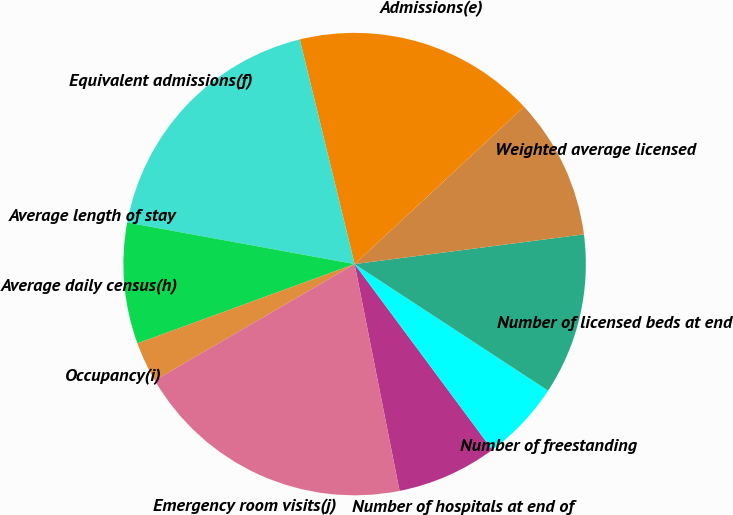<chart> <loc_0><loc_0><loc_500><loc_500><pie_chart><fcel>Number of hospitals at end of<fcel>Number of freestanding<fcel>Number of licensed beds at end<fcel>Weighted average licensed<fcel>Admissions(e)<fcel>Equivalent admissions(f)<fcel>Average length of stay<fcel>Average daily census(h)<fcel>Occupancy(i)<fcel>Emergency room visits(j)<nl><fcel>7.04%<fcel>5.63%<fcel>11.27%<fcel>9.86%<fcel>16.9%<fcel>18.31%<fcel>0.0%<fcel>8.45%<fcel>2.82%<fcel>19.72%<nl></chart> 